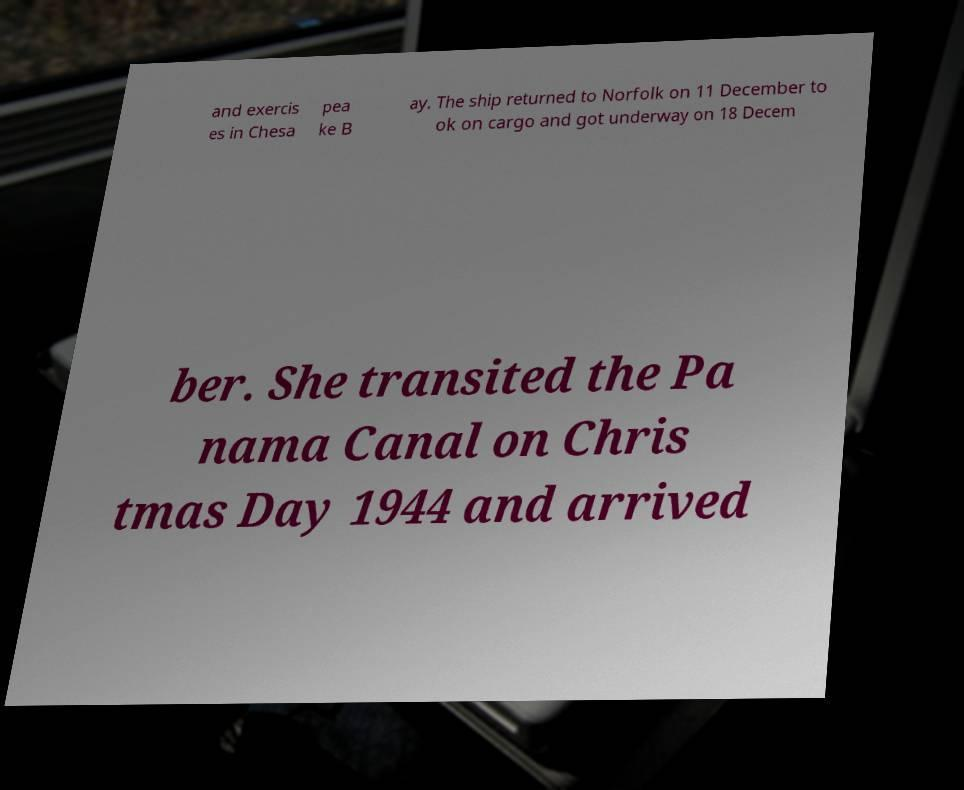Please identify and transcribe the text found in this image. and exercis es in Chesa pea ke B ay. The ship returned to Norfolk on 11 December to ok on cargo and got underway on 18 Decem ber. She transited the Pa nama Canal on Chris tmas Day 1944 and arrived 